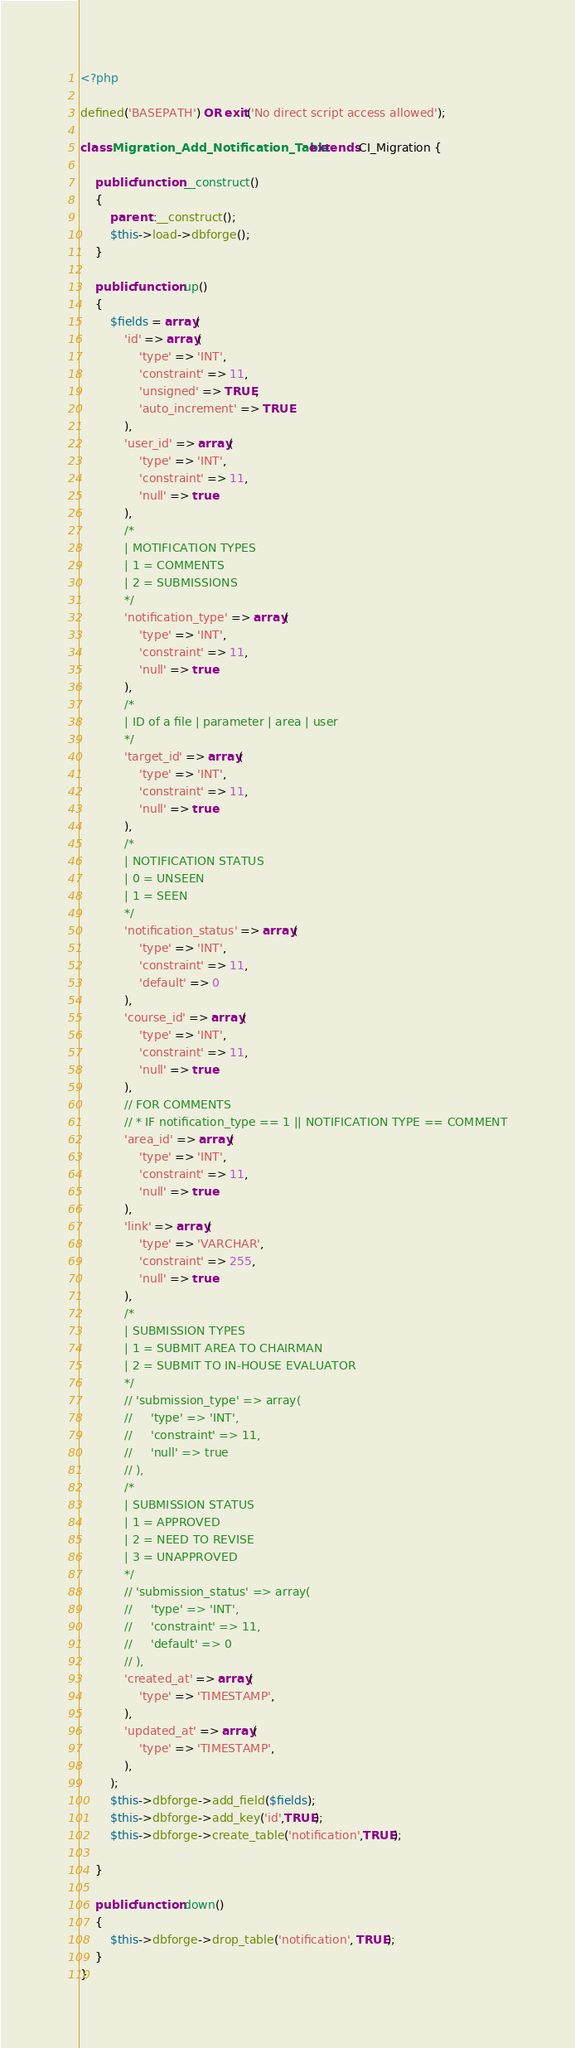<code> <loc_0><loc_0><loc_500><loc_500><_PHP_><?php

defined('BASEPATH') OR exit('No direct script access allowed');

class Migration_Add_Notification_Table extends CI_Migration {

    public function __construct()
    {
        parent::__construct();
        $this->load->dbforge();
    }

    public function up()
    {
        $fields = array(
            'id' => array(
                'type' => 'INT',
                'constraint' => 11,
                'unsigned' => TRUE,
                'auto_increment' => TRUE
            ),
            'user_id' => array(
                'type' => 'INT',
                'constraint' => 11,
                'null' => true
            ),
            /*
            | MOTIFICATION TYPES
            | 1 = COMMENTS
            | 2 = SUBMISSIONS
            */ 
            'notification_type' => array(
                'type' => 'INT',
                'constraint' => 11,
                'null' => true
            ),
            /*
            | ID of a file | parameter | area | user
            */  
            'target_id' => array( 
                'type' => 'INT',
                'constraint' => 11,
                'null' => true
            ),            
            /*
            | NOTIFICATION STATUS
            | 0 = UNSEEN
            | 1 = SEEN
            */ 
            'notification_status' => array(
                'type' => 'INT',
                'constraint' => 11,
                'default' => 0
            ),
            'course_id' => array(
                'type' => 'INT',
                'constraint' => 11,
                'null' => true
            ),
            // FOR COMMENTS
            // * IF notification_type == 1 || NOTIFICATION TYPE == COMMENT
            'area_id' => array(
                'type' => 'INT',
                'constraint' => 11,
                'null' => true
            ),
            'link' => array(
                'type' => 'VARCHAR',
                'constraint' => 255,
                'null' => true
            ),
            /*
            | SUBMISSION TYPES
            | 1 = SUBMIT AREA TO CHAIRMAN 
            | 2 = SUBMIT TO IN-HOUSE EVALUATOR 
            */             
            // 'submission_type' => array(
            //     'type' => 'INT',
            //     'constraint' => 11,
            //     'null' => true
            // ),
            /*
            | SUBMISSION STATUS
            | 1 = APPROVED 
            | 2 = NEED TO REVISE
            | 3 = UNAPPROVED 
            */  
            // 'submission_status' => array(
            //     'type' => 'INT',
            //     'constraint' => 11,
            //     'default' => 0
            // ),
            'created_at' => array(
                'type' => 'TIMESTAMP',
            ),
            'updated_at' => array(
                'type' => 'TIMESTAMP',
            ),
        );
        $this->dbforge->add_field($fields);
        $this->dbforge->add_key('id',TRUE);
        $this->dbforge->create_table('notification',TRUE); 

    }

    public function down()
    {
        $this->dbforge->drop_table('notification', TRUE);
    }
}</code> 